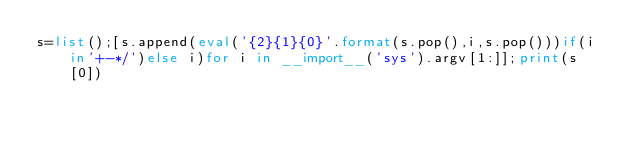Convert code to text. <code><loc_0><loc_0><loc_500><loc_500><_Python_>s=list();[s.append(eval('{2}{1}{0}'.format(s.pop(),i,s.pop()))if(i in'+-*/')else i)for i in __import__('sys').argv[1:]];print(s[0])</code> 